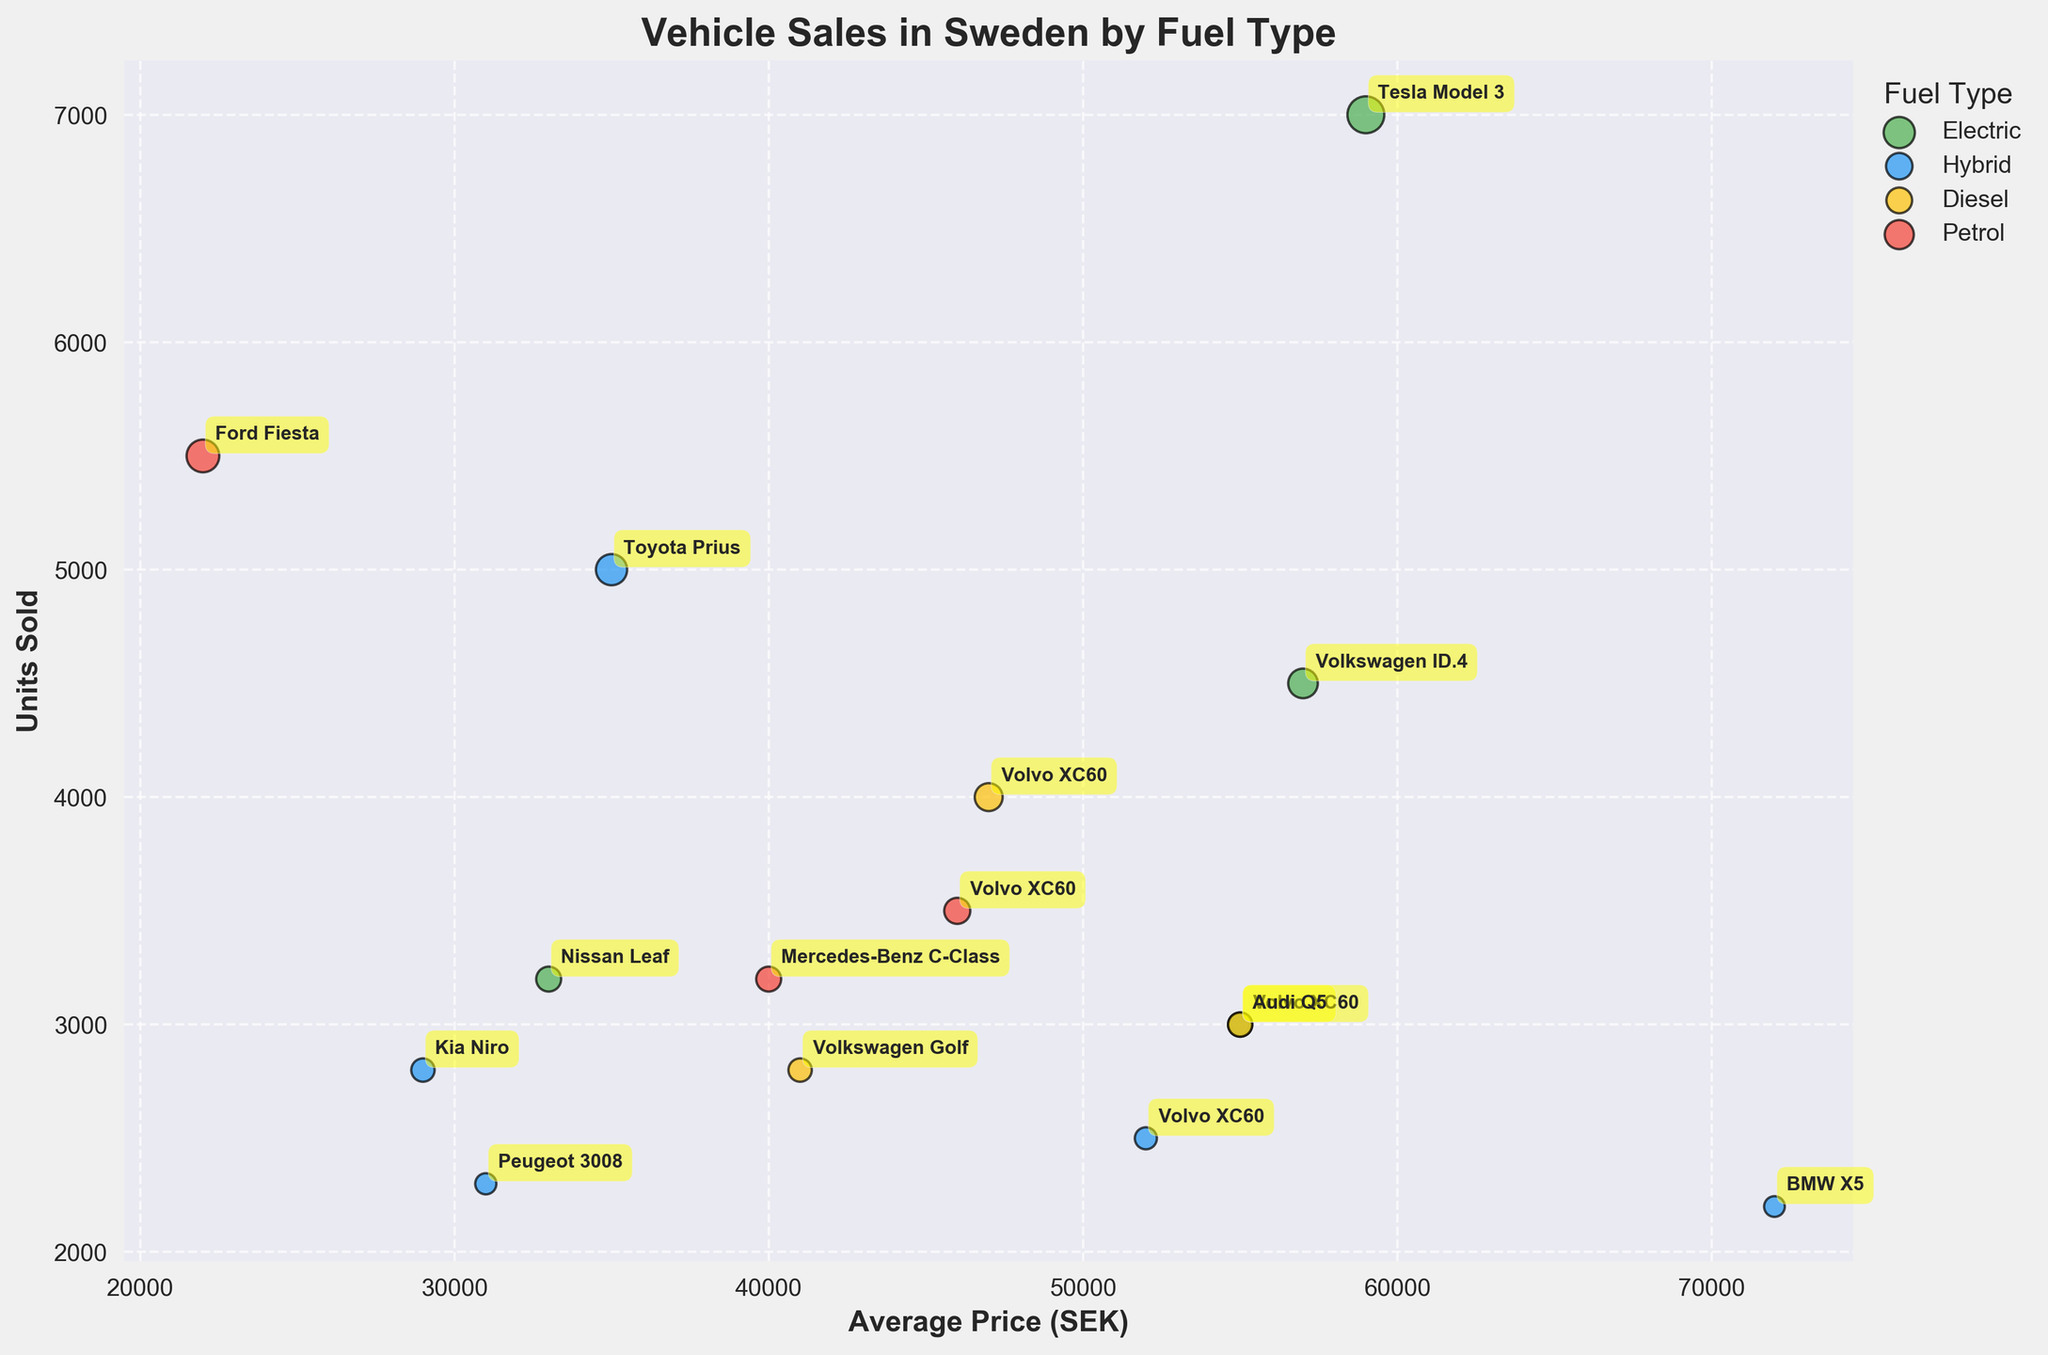Which vehicle type has the highest units sold? The bubble with the highest value on the y-axis represents the Tesla Model 3, which has 7000 units sold.
Answer: Tesla Model 3 What is the average price and units sold of the Volvo XC60 Diesel? Locate the bubble for Volvo XC60 Diesel. Its Average Price is 47000 SEK and it has 4000 units sold as indicated by the bubble's position and size.
Answer: 47000 SEK and 4000 units Which fuel type has the most expensive average price overall? By scanning the bubbles' positions on the x-axis, Hybrid fuel types, especially vehicles like BMW X5, have high average prices. The BMW X5 hybrid, in particular, has 72000 SEK.
Answer: Hybrid How does the units sold for Ford Fiesta compare to that for Volkswagen ID.4? Ford Fiesta has 5500 units sold, whereas Volkswagen ID.4 has 4500 units. This means more units of Ford Fiesta were sold compared to the Volkswagen ID.4.
Answer: Ford Fiesta has more units sold What is the relationship between the average price and units sold for electric vehicles? Observe the bubbles of electric vehicles and their distribution. The Tesla Model 3, with a high average price and high units sold, dominates, indicating a relatively strong inverse relationship where higher-priced electric vehicles also have high sales.
Answer: Inverse relationship What are the units sold of vehicles with an average price above 60000 SEK? Check the bubbles positioned on the right of 60000 SEK on the x-axis. Only the BMW X5 (unit sold: 2200) has an average price above 60000 SEK and known units sold visualized in the plot.
Answer: 2200 units Which electric vehicle has the lowest average price and how many units were sold? Among electric vehicles, the Nissan Leaf has the lowest average price at 33000 SEK, with units sold of 3200.
Answer: Nissan Leaf, 3200 units What is the combined units sold for all hybrid vehicles? Add units sold for all hybrid vehicles: 2500 (Volvo XC60) + 5000 (Toyota Prius) + 2200 (BMW X5) + 2800 (Kia Niro) + 2300 (Peugeot 3008) = 14800 units.
Answer: 14800 units Is there any vehicle with over 5000 units sold and priced above 35000 SEK? Identify bubbles with units sold over 5000. Only the Tesla Model 3 (units: 7000, price: 59000 SEK) and Ford Fiesta (units: 5500, price: 22000 SEK) crossed 5000. Out of these, only the Tesla Model 3 has an average price above 35000 SEK.
Answer: Tesla Model 3 How many petrol vehicles have average prices over 30000 SEK? Identify the bubbles for petrol vehicles. Mercedes-Benz C-Class (average price 40000 SEK) and Volvo XC60 (average price 46000 SEK) are petrol vehicles priced over 30000 SEK, totaling 2.
Answer: 2 vehicles 